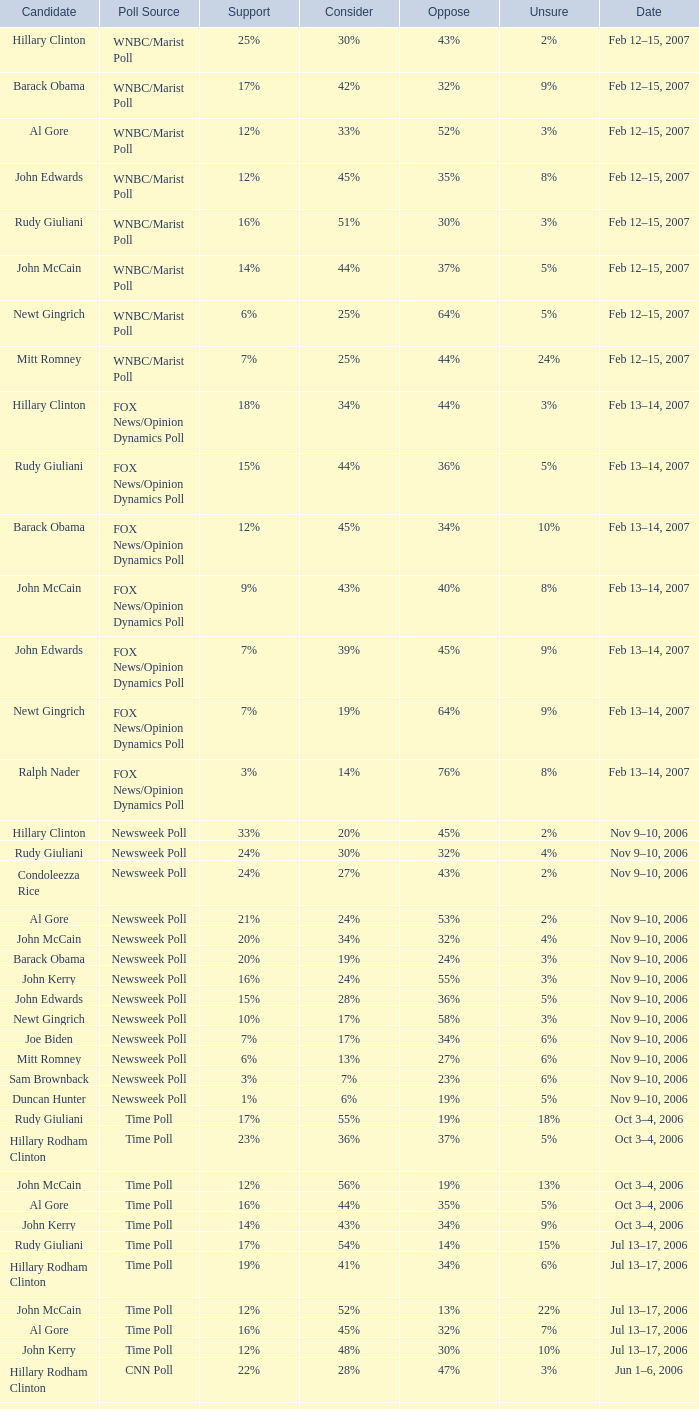What percentage of people said they would consider Rudy Giuliani as a candidate according to the Newsweek poll that showed 32% opposed him? 30%. 